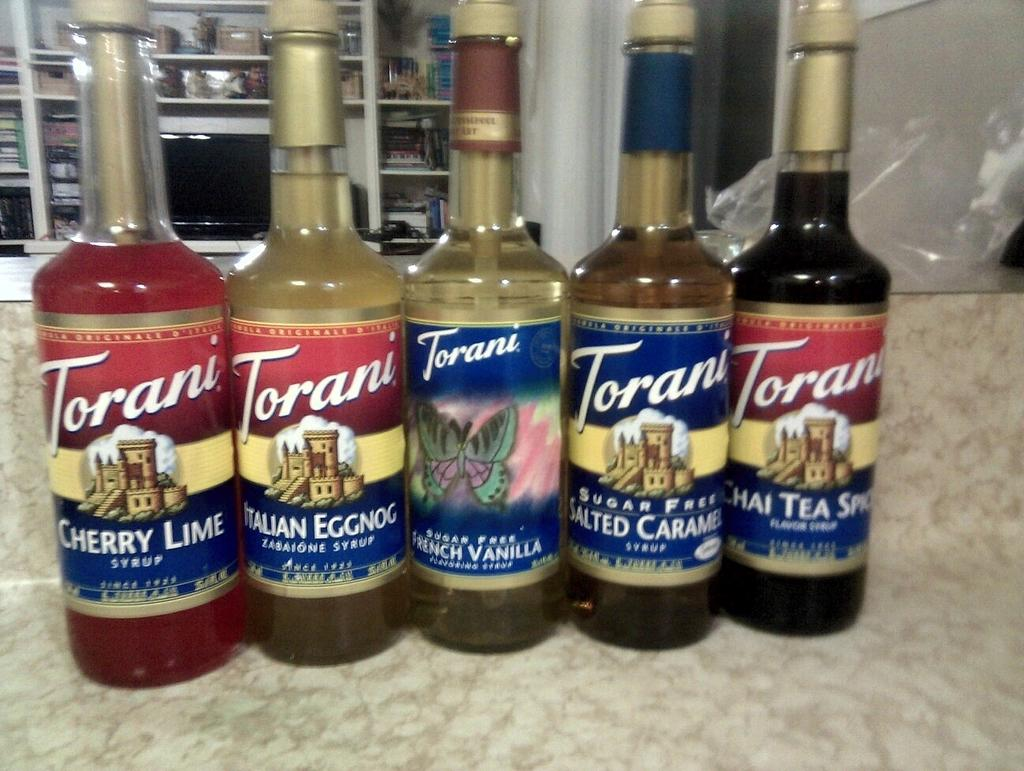<image>
Describe the image concisely. Five bottles of syrup from the brand named Torani. 